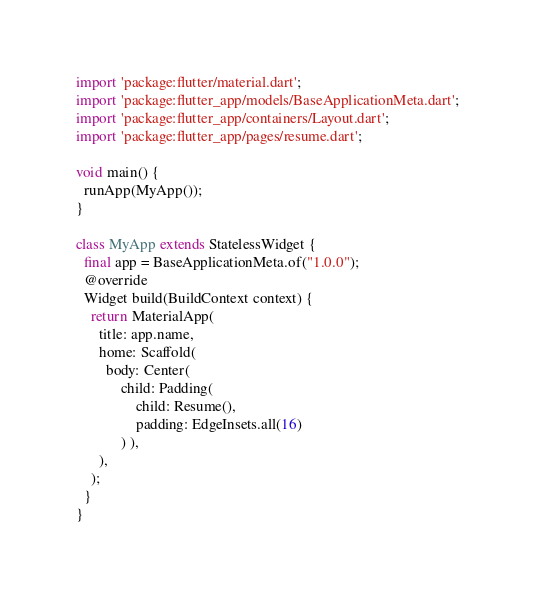Convert code to text. <code><loc_0><loc_0><loc_500><loc_500><_Dart_>import 'package:flutter/material.dart';
import 'package:flutter_app/models/BaseApplicationMeta.dart';
import 'package:flutter_app/containers/Layout.dart';
import 'package:flutter_app/pages/resume.dart';

void main() {
  runApp(MyApp());
}

class MyApp extends StatelessWidget {
  final app = BaseApplicationMeta.of("1.0.0");
  @override
  Widget build(BuildContext context) {
    return MaterialApp(
      title: app.name,
      home: Scaffold(
        body: Center(
            child: Padding(
                child: Resume(),
                padding: EdgeInsets.all(16)
            ) ),
      ),
    );
  }
}
</code> 